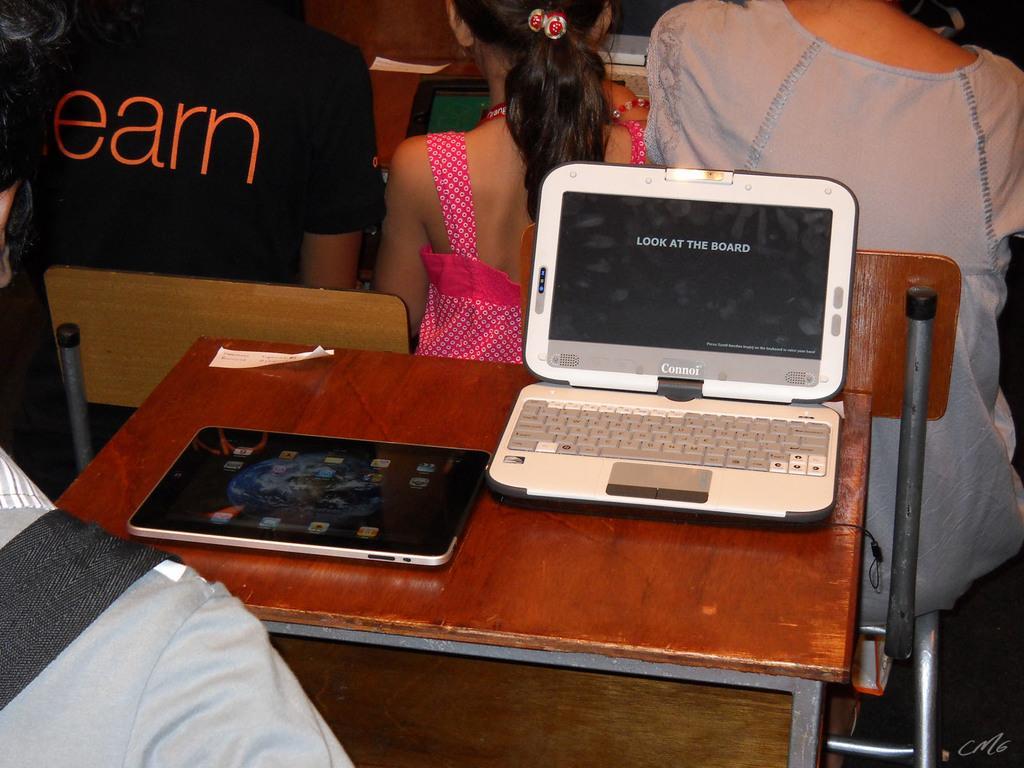Could you give a brief overview of what you see in this image? In the image we can see there is a table on which there is a laptop and ipad and there are people are sitting on chair. 